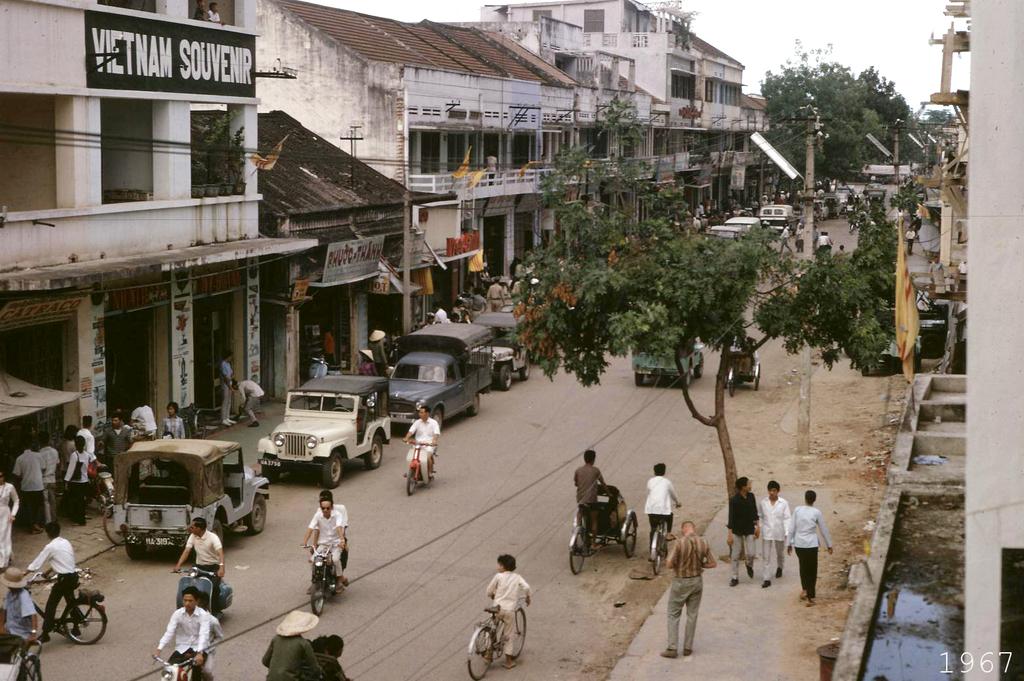What country is this according to the sign?
Ensure brevity in your answer.  Vietnam. 